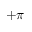<formula> <loc_0><loc_0><loc_500><loc_500>+ \pi</formula> 